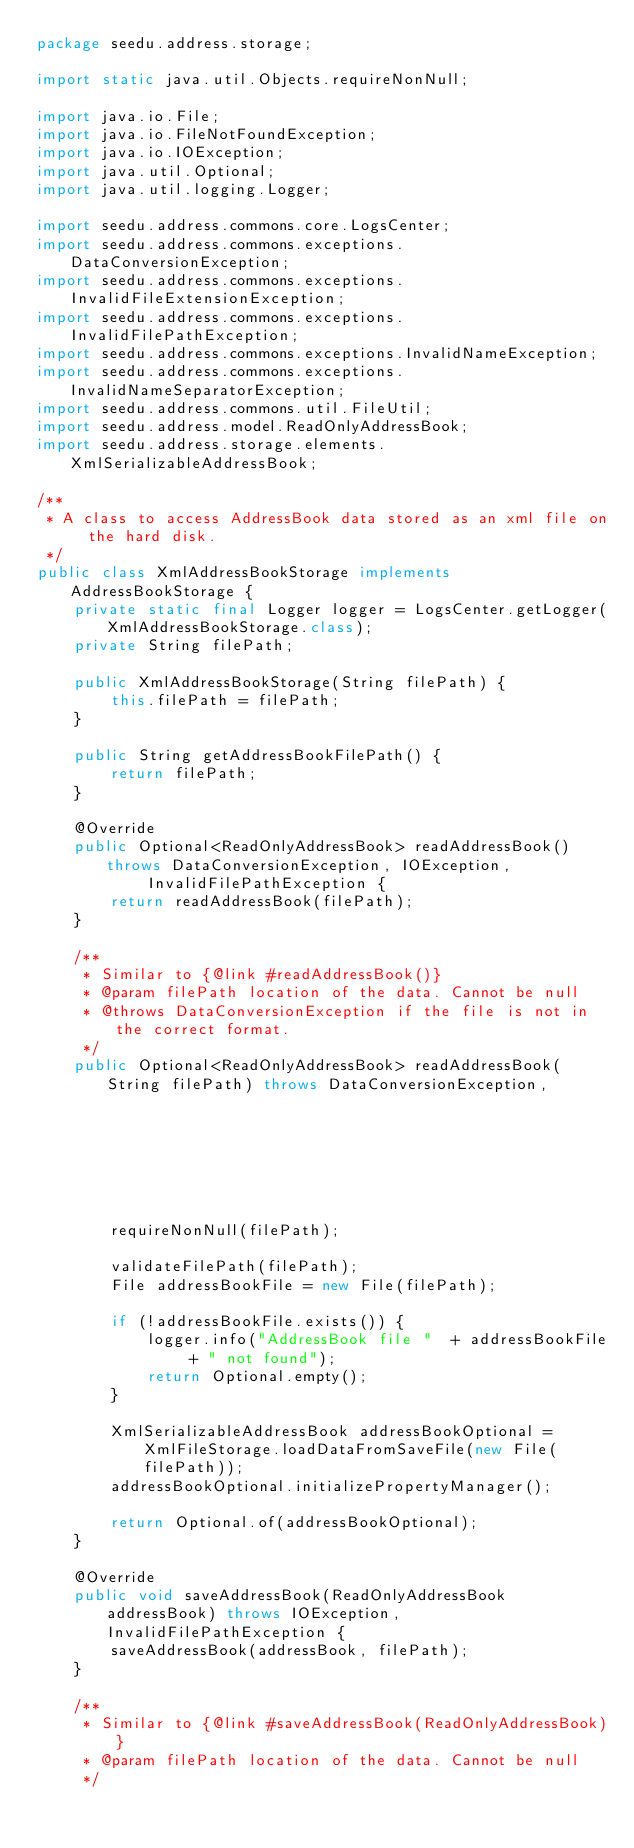Convert code to text. <code><loc_0><loc_0><loc_500><loc_500><_Java_>package seedu.address.storage;

import static java.util.Objects.requireNonNull;

import java.io.File;
import java.io.FileNotFoundException;
import java.io.IOException;
import java.util.Optional;
import java.util.logging.Logger;

import seedu.address.commons.core.LogsCenter;
import seedu.address.commons.exceptions.DataConversionException;
import seedu.address.commons.exceptions.InvalidFileExtensionException;
import seedu.address.commons.exceptions.InvalidFilePathException;
import seedu.address.commons.exceptions.InvalidNameException;
import seedu.address.commons.exceptions.InvalidNameSeparatorException;
import seedu.address.commons.util.FileUtil;
import seedu.address.model.ReadOnlyAddressBook;
import seedu.address.storage.elements.XmlSerializableAddressBook;

/**
 * A class to access AddressBook data stored as an xml file on the hard disk.
 */
public class XmlAddressBookStorage implements AddressBookStorage {
    private static final Logger logger = LogsCenter.getLogger(XmlAddressBookStorage.class);
    private String filePath;

    public XmlAddressBookStorage(String filePath) {
        this.filePath = filePath;
    }

    public String getAddressBookFilePath() {
        return filePath;
    }

    @Override
    public Optional<ReadOnlyAddressBook> readAddressBook() throws DataConversionException, IOException,
            InvalidFilePathException {
        return readAddressBook(filePath);
    }

    /**
     * Similar to {@link #readAddressBook()}
     * @param filePath location of the data. Cannot be null
     * @throws DataConversionException if the file is not in the correct format.
     */
    public Optional<ReadOnlyAddressBook> readAddressBook(String filePath) throws DataConversionException,
                                                                                 FileNotFoundException,
                                                                                 InvalidFilePathException {
        requireNonNull(filePath);

        validateFilePath(filePath);
        File addressBookFile = new File(filePath);

        if (!addressBookFile.exists()) {
            logger.info("AddressBook file "  + addressBookFile + " not found");
            return Optional.empty();
        }

        XmlSerializableAddressBook addressBookOptional = XmlFileStorage.loadDataFromSaveFile(new File(filePath));
        addressBookOptional.initializePropertyManager();

        return Optional.of(addressBookOptional);
    }

    @Override
    public void saveAddressBook(ReadOnlyAddressBook addressBook) throws IOException, InvalidFilePathException {
        saveAddressBook(addressBook, filePath);
    }

    /**
     * Similar to {@link #saveAddressBook(ReadOnlyAddressBook)}
     * @param filePath location of the data. Cannot be null
     */</code> 